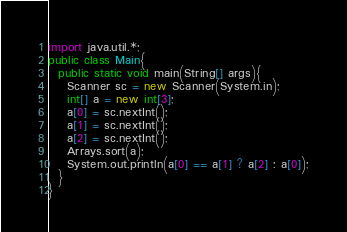Convert code to text. <code><loc_0><loc_0><loc_500><loc_500><_Java_>import java.util.*;
public class Main{
  public static void main(String[] args){
    Scanner sc = new Scanner(System.in);
    int[] a = new int[3];
    a[0] = sc.nextInt();
    a[1] = sc.nextInt();
    a[2] = sc.nextInt();
    Arrays.sort(a);
    System.out.println(a[0] == a[1] ? a[2] : a[0]);
  }
}</code> 